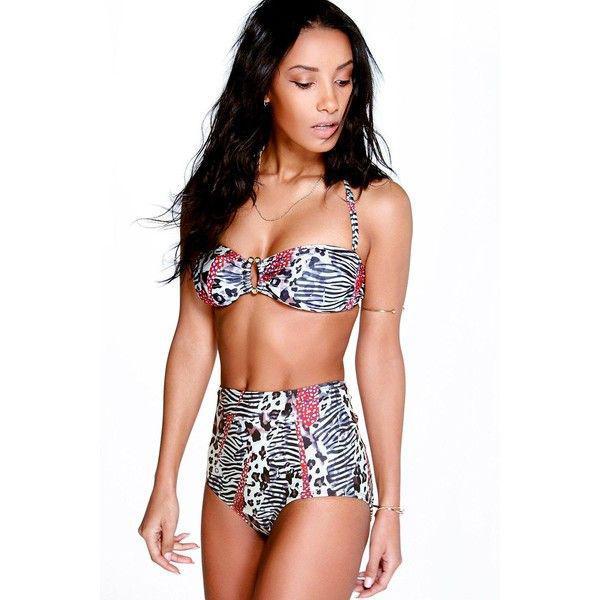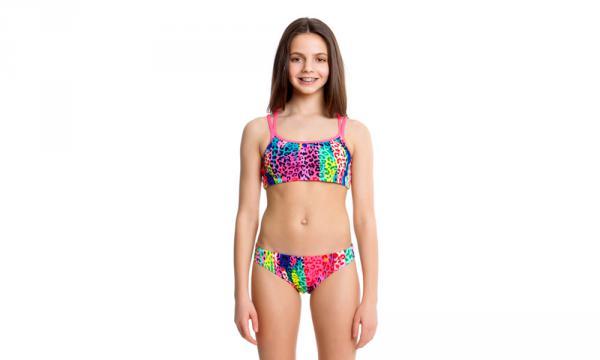The first image is the image on the left, the second image is the image on the right. Assess this claim about the two images: "At least one model wears a bikini with completely different patterns on the top and bottom.". Correct or not? Answer yes or no. No. The first image is the image on the left, the second image is the image on the right. For the images displayed, is the sentence "One woman has her hand on her hip." factually correct? Answer yes or no. No. 